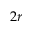Convert formula to latex. <formula><loc_0><loc_0><loc_500><loc_500>2 r</formula> 